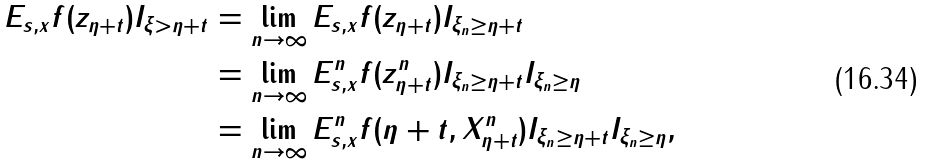<formula> <loc_0><loc_0><loc_500><loc_500>E _ { s , x } f ( z _ { \eta + t } ) I _ { \xi > \eta + t } & = \lim _ { n \rightarrow \infty } E _ { s , x } f ( z _ { \eta + t } ) I _ { \xi _ { n } \geq \eta + t } \\ & = \lim _ { n \rightarrow \infty } E _ { s , x } ^ { n } f ( z _ { \eta + t } ^ { n } ) I _ { \xi _ { n } \geq \eta + t } I _ { \xi _ { n } \geq \eta } \\ & = \lim _ { n \rightarrow \infty } E _ { s , x } ^ { n } f ( \eta + t , X _ { \eta + t } ^ { n } ) I _ { \xi _ { n } \geq \eta + t } I _ { \xi _ { n } \geq \eta } ,</formula> 